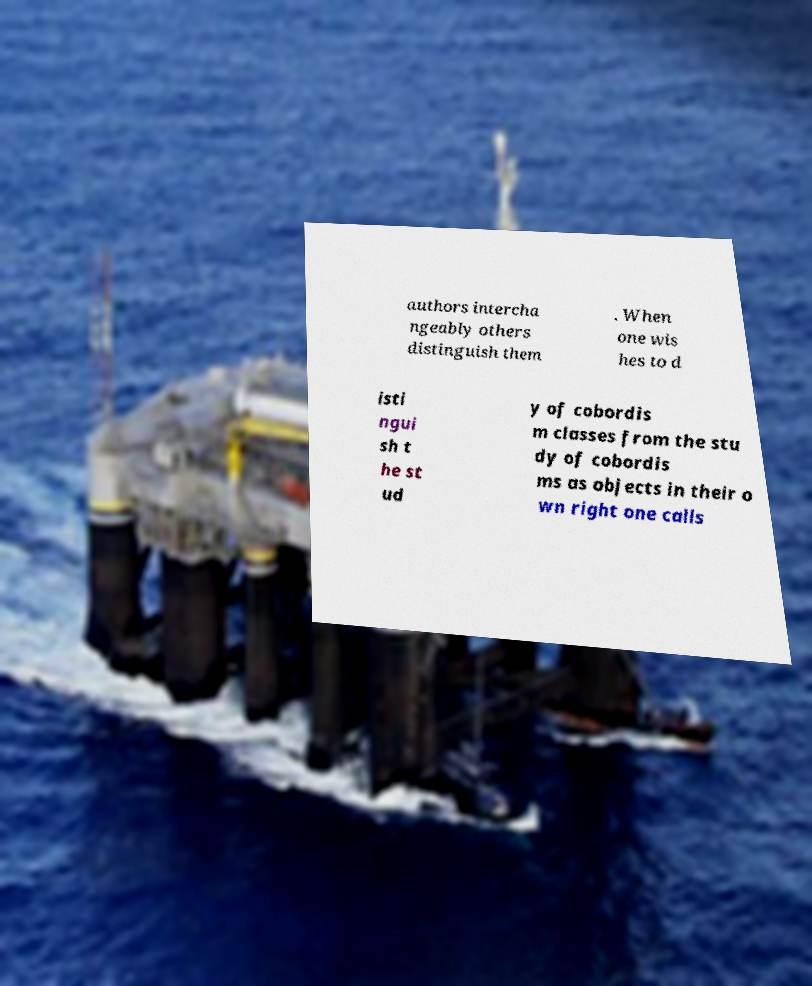Can you accurately transcribe the text from the provided image for me? authors intercha ngeably others distinguish them . When one wis hes to d isti ngui sh t he st ud y of cobordis m classes from the stu dy of cobordis ms as objects in their o wn right one calls 